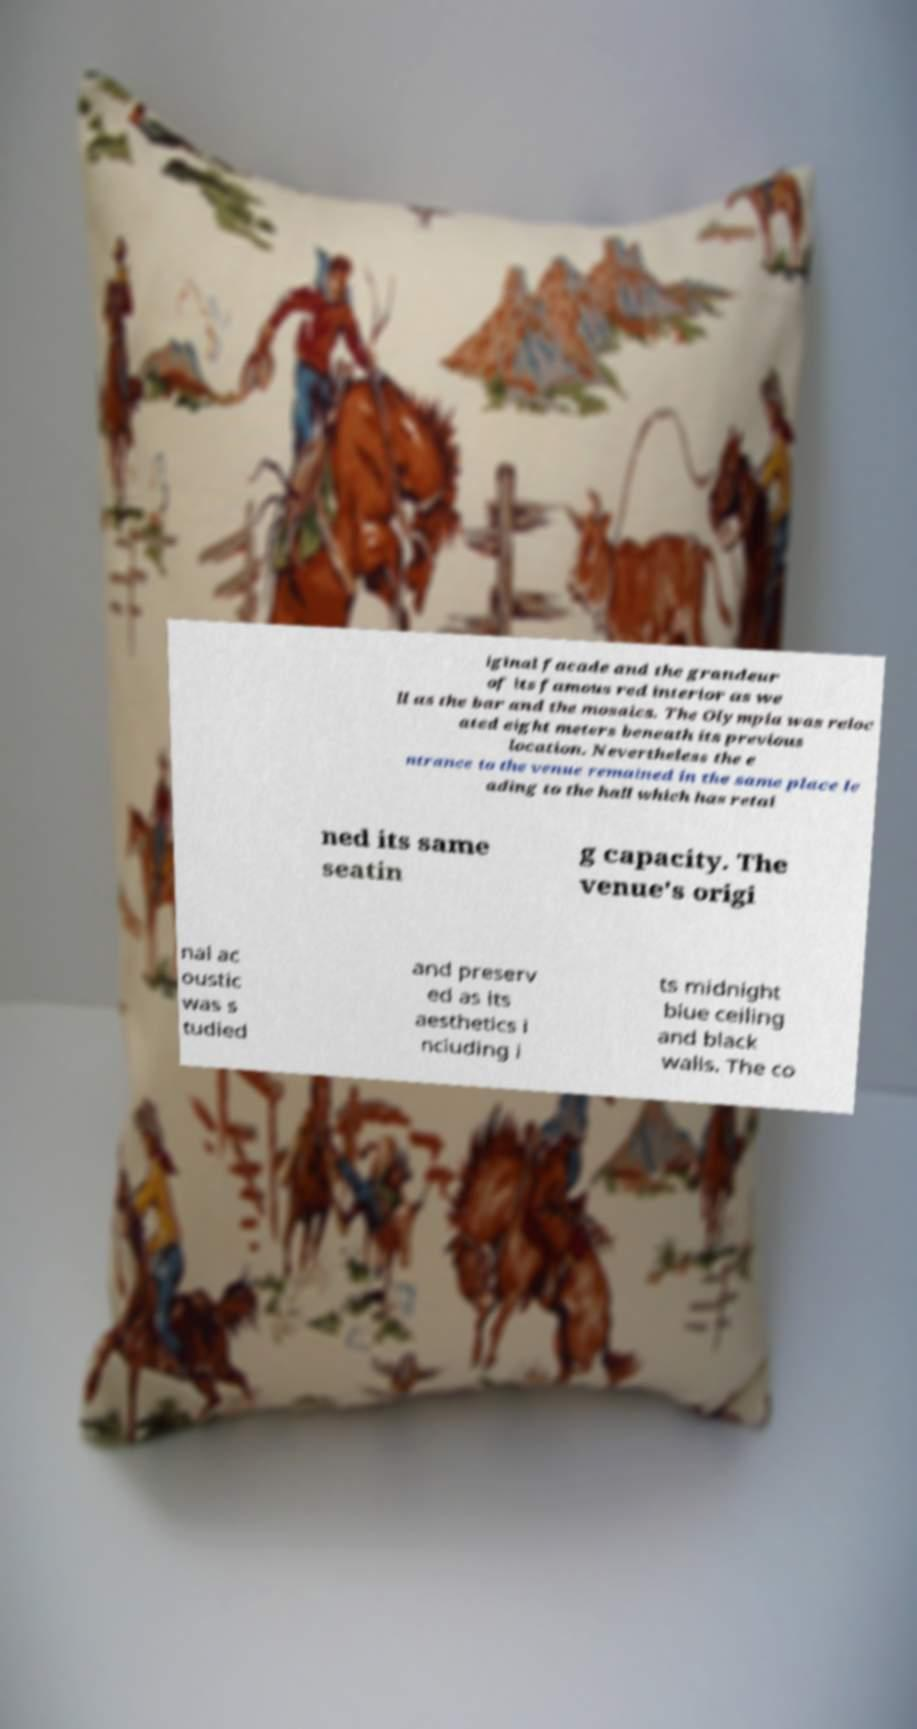Could you assist in decoding the text presented in this image and type it out clearly? iginal facade and the grandeur of its famous red interior as we ll as the bar and the mosaics. The Olympia was reloc ated eight meters beneath its previous location. Nevertheless the e ntrance to the venue remained in the same place le ading to the hall which has retai ned its same seatin g capacity. The venue's origi nal ac oustic was s tudied and preserv ed as its aesthetics i ncluding i ts midnight blue ceiling and black walls. The co 